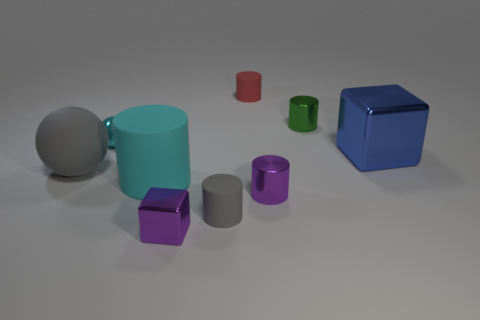What is the material of the thing that is the same color as the large rubber cylinder?
Provide a short and direct response. Metal. What number of matte objects are either large objects or red objects?
Your answer should be compact. 3. Is the shape of the cyan object that is on the left side of the cyan cylinder the same as the gray thing on the left side of the cyan sphere?
Provide a short and direct response. Yes. There is a big blue cube; how many things are on the right side of it?
Offer a very short reply. 0. Is there a big blue object made of the same material as the big cylinder?
Give a very brief answer. No. What is the material of the cyan object that is the same size as the green metallic cylinder?
Offer a terse response. Metal. Is the small red thing made of the same material as the tiny purple cylinder?
Ensure brevity in your answer.  No. How many objects are either large metallic things or small green cylinders?
Offer a very short reply. 2. What shape is the small rubber thing that is behind the blue thing?
Provide a succinct answer. Cylinder. What color is the big block that is the same material as the green cylinder?
Offer a very short reply. Blue. 